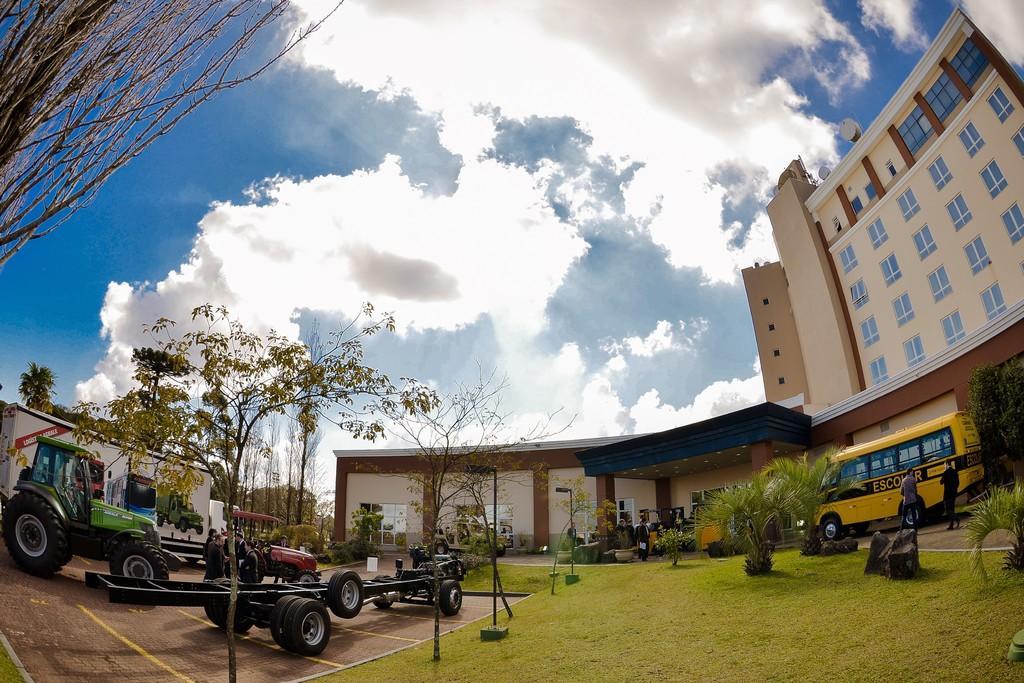Could you give a brief overview of what you see in this image? This image consists of a building along with windows. At the bottom, there is green grass along with plants. To the left, there are vehicles. At the top, there are clouds in the sky. 